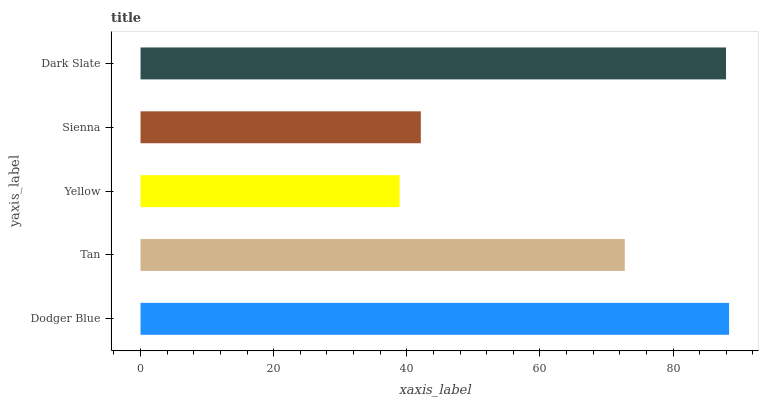Is Yellow the minimum?
Answer yes or no. Yes. Is Dodger Blue the maximum?
Answer yes or no. Yes. Is Tan the minimum?
Answer yes or no. No. Is Tan the maximum?
Answer yes or no. No. Is Dodger Blue greater than Tan?
Answer yes or no. Yes. Is Tan less than Dodger Blue?
Answer yes or no. Yes. Is Tan greater than Dodger Blue?
Answer yes or no. No. Is Dodger Blue less than Tan?
Answer yes or no. No. Is Tan the high median?
Answer yes or no. Yes. Is Tan the low median?
Answer yes or no. Yes. Is Dodger Blue the high median?
Answer yes or no. No. Is Dark Slate the low median?
Answer yes or no. No. 